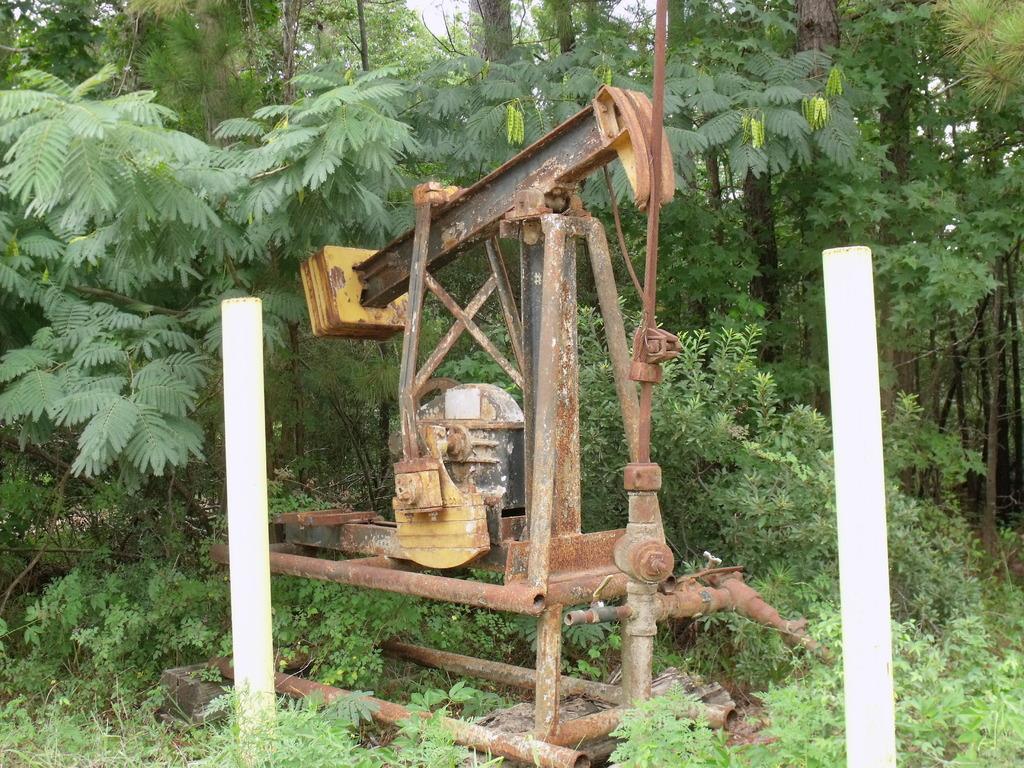Describe this image in one or two sentences. In this picture there is a machine and there are poles. At the back there are trees. At the top there is sky. At the bottom there are plants. 